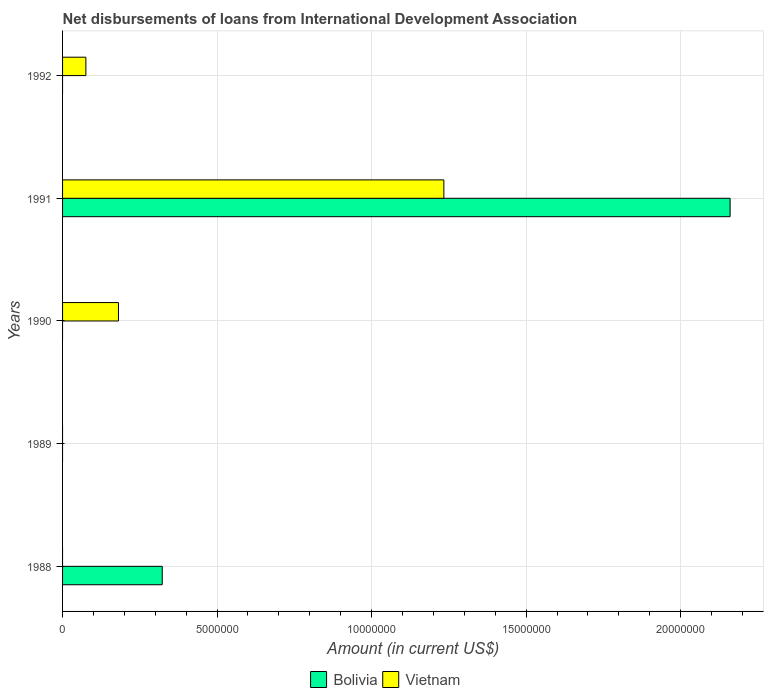How many different coloured bars are there?
Offer a terse response. 2. Are the number of bars per tick equal to the number of legend labels?
Your answer should be compact. No. How many bars are there on the 1st tick from the top?
Offer a terse response. 1. How many bars are there on the 3rd tick from the bottom?
Your response must be concise. 1. In how many cases, is the number of bars for a given year not equal to the number of legend labels?
Provide a short and direct response. 4. What is the amount of loans disbursed in Bolivia in 1988?
Give a very brief answer. 3.22e+06. Across all years, what is the maximum amount of loans disbursed in Bolivia?
Offer a terse response. 2.16e+07. In which year was the amount of loans disbursed in Vietnam maximum?
Offer a very short reply. 1991. What is the total amount of loans disbursed in Vietnam in the graph?
Keep it short and to the point. 1.49e+07. What is the difference between the amount of loans disbursed in Bolivia in 1988 and that in 1991?
Offer a terse response. -1.84e+07. What is the difference between the amount of loans disbursed in Vietnam in 1990 and the amount of loans disbursed in Bolivia in 1992?
Your response must be concise. 1.81e+06. What is the average amount of loans disbursed in Vietnam per year?
Offer a very short reply. 2.98e+06. In the year 1991, what is the difference between the amount of loans disbursed in Bolivia and amount of loans disbursed in Vietnam?
Make the answer very short. 9.26e+06. In how many years, is the amount of loans disbursed in Vietnam greater than 21000000 US$?
Ensure brevity in your answer.  0. Is the amount of loans disbursed in Bolivia in 1988 less than that in 1991?
Provide a short and direct response. Yes. What is the difference between the highest and the second highest amount of loans disbursed in Vietnam?
Ensure brevity in your answer.  1.05e+07. What is the difference between the highest and the lowest amount of loans disbursed in Vietnam?
Provide a short and direct response. 1.23e+07. Is the sum of the amount of loans disbursed in Vietnam in 1990 and 1992 greater than the maximum amount of loans disbursed in Bolivia across all years?
Your response must be concise. No. Are all the bars in the graph horizontal?
Offer a terse response. Yes. How many years are there in the graph?
Your response must be concise. 5. What is the difference between two consecutive major ticks on the X-axis?
Your answer should be very brief. 5.00e+06. Does the graph contain any zero values?
Provide a succinct answer. Yes. How many legend labels are there?
Your answer should be very brief. 2. What is the title of the graph?
Your response must be concise. Net disbursements of loans from International Development Association. Does "East Asia (all income levels)" appear as one of the legend labels in the graph?
Offer a very short reply. No. What is the label or title of the X-axis?
Offer a very short reply. Amount (in current US$). What is the Amount (in current US$) in Bolivia in 1988?
Ensure brevity in your answer.  3.22e+06. What is the Amount (in current US$) of Vietnam in 1990?
Offer a terse response. 1.81e+06. What is the Amount (in current US$) in Bolivia in 1991?
Your response must be concise. 2.16e+07. What is the Amount (in current US$) of Vietnam in 1991?
Provide a succinct answer. 1.23e+07. What is the Amount (in current US$) in Bolivia in 1992?
Your answer should be very brief. 0. What is the Amount (in current US$) in Vietnam in 1992?
Keep it short and to the point. 7.54e+05. Across all years, what is the maximum Amount (in current US$) in Bolivia?
Offer a terse response. 2.16e+07. Across all years, what is the maximum Amount (in current US$) in Vietnam?
Ensure brevity in your answer.  1.23e+07. Across all years, what is the minimum Amount (in current US$) in Bolivia?
Provide a short and direct response. 0. Across all years, what is the minimum Amount (in current US$) in Vietnam?
Provide a short and direct response. 0. What is the total Amount (in current US$) of Bolivia in the graph?
Ensure brevity in your answer.  2.48e+07. What is the total Amount (in current US$) in Vietnam in the graph?
Offer a terse response. 1.49e+07. What is the difference between the Amount (in current US$) in Bolivia in 1988 and that in 1991?
Offer a terse response. -1.84e+07. What is the difference between the Amount (in current US$) of Vietnam in 1990 and that in 1991?
Your answer should be very brief. -1.05e+07. What is the difference between the Amount (in current US$) of Vietnam in 1990 and that in 1992?
Your answer should be very brief. 1.06e+06. What is the difference between the Amount (in current US$) in Vietnam in 1991 and that in 1992?
Your answer should be compact. 1.16e+07. What is the difference between the Amount (in current US$) in Bolivia in 1988 and the Amount (in current US$) in Vietnam in 1990?
Give a very brief answer. 1.42e+06. What is the difference between the Amount (in current US$) in Bolivia in 1988 and the Amount (in current US$) in Vietnam in 1991?
Your answer should be compact. -9.11e+06. What is the difference between the Amount (in current US$) of Bolivia in 1988 and the Amount (in current US$) of Vietnam in 1992?
Keep it short and to the point. 2.47e+06. What is the difference between the Amount (in current US$) of Bolivia in 1991 and the Amount (in current US$) of Vietnam in 1992?
Offer a terse response. 2.08e+07. What is the average Amount (in current US$) of Bolivia per year?
Make the answer very short. 4.97e+06. What is the average Amount (in current US$) of Vietnam per year?
Ensure brevity in your answer.  2.98e+06. In the year 1991, what is the difference between the Amount (in current US$) of Bolivia and Amount (in current US$) of Vietnam?
Your answer should be compact. 9.26e+06. What is the ratio of the Amount (in current US$) of Bolivia in 1988 to that in 1991?
Provide a short and direct response. 0.15. What is the ratio of the Amount (in current US$) of Vietnam in 1990 to that in 1991?
Your response must be concise. 0.15. What is the ratio of the Amount (in current US$) in Vietnam in 1990 to that in 1992?
Your answer should be very brief. 2.4. What is the ratio of the Amount (in current US$) of Vietnam in 1991 to that in 1992?
Your answer should be very brief. 16.36. What is the difference between the highest and the second highest Amount (in current US$) of Vietnam?
Make the answer very short. 1.05e+07. What is the difference between the highest and the lowest Amount (in current US$) in Bolivia?
Provide a succinct answer. 2.16e+07. What is the difference between the highest and the lowest Amount (in current US$) in Vietnam?
Give a very brief answer. 1.23e+07. 